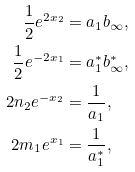Convert formula to latex. <formula><loc_0><loc_0><loc_500><loc_500>\frac { 1 } { 2 } e ^ { 2 x _ { 2 } } & = a _ { 1 } b _ { \infty } , \\ \frac { 1 } { 2 } e ^ { - 2 x _ { 1 } } & = a ^ { * } _ { 1 } b ^ { * } _ { \infty } , \\ 2 n _ { 2 } e ^ { - x _ { 2 } } & = \frac { 1 } { a _ { 1 } } , \\ 2 m _ { 1 } e ^ { x _ { 1 } } & = \frac { 1 } { a _ { 1 } ^ { * } } , \\</formula> 